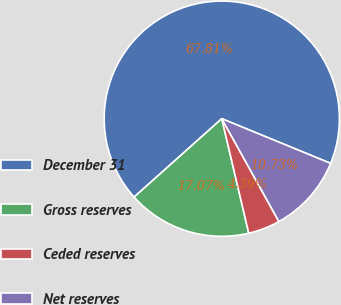Convert chart. <chart><loc_0><loc_0><loc_500><loc_500><pie_chart><fcel>December 31<fcel>Gross reserves<fcel>Ceded reserves<fcel>Net reserves<nl><fcel>67.81%<fcel>17.07%<fcel>4.39%<fcel>10.73%<nl></chart> 